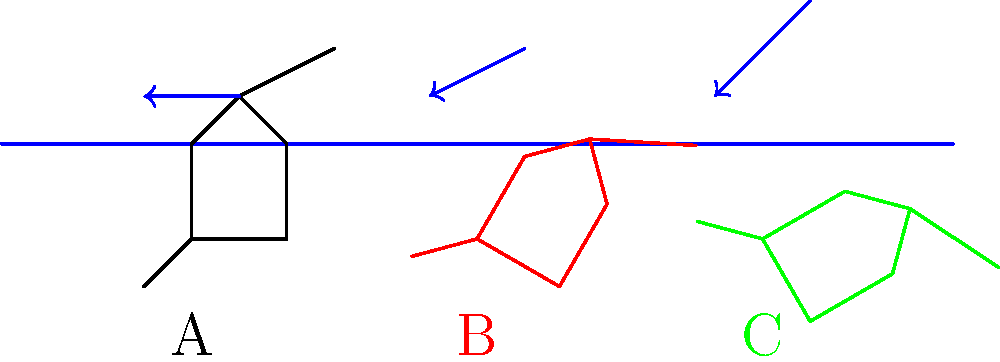As a professional sports coach, you're analyzing different swimming stroke techniques. The image shows three swimmers (A, B, and C) with varying arm positions relative to the water surface. Which swimmer's arm position is likely to generate the most efficient stroke in terms of propulsion and reduced water resistance? To determine the most efficient stroke, we need to consider two main factors: propulsion and water resistance.

1. Propulsion:
   - Swimmer A has a horizontal arm position, which provides minimal surface area for pushing against the water.
   - Swimmer B has a slightly angled arm, increasing the surface area for propulsion.
   - Swimmer C has the most angled arm, providing the largest surface area for pushing against the water.

2. Water resistance:
   - Swimmer A experiences the least water resistance due to the streamlined position of the arm.
   - Swimmer B encounters slightly more resistance as the arm begins to push against the water flow.
   - Swimmer C faces the highest water resistance due to the arm's more vertical position.

3. Efficiency analysis:
   - The ideal stroke balances maximum propulsion with minimum resistance.
   - Swimmer A has minimal resistance but also minimal propulsion.
   - Swimmer C has maximum propulsion but also maximum resistance.
   - Swimmer B strikes a balance between propulsion and resistance.

4. Biomechanical principle:
   - The most efficient stroke typically occurs at an angle of about 30-40 degrees relative to the water surface.
   - This angle allows for significant propulsion while maintaining a relatively streamlined position.

5. Conclusion:
   - Swimmer B's arm position most closely approximates the ideal angle for swimming efficiency.
Answer: Swimmer B 